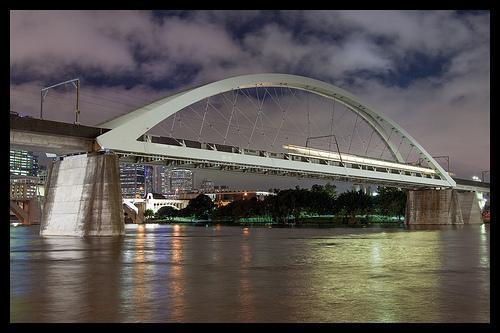How many bridges are in the picture?
Give a very brief answer. 1. 